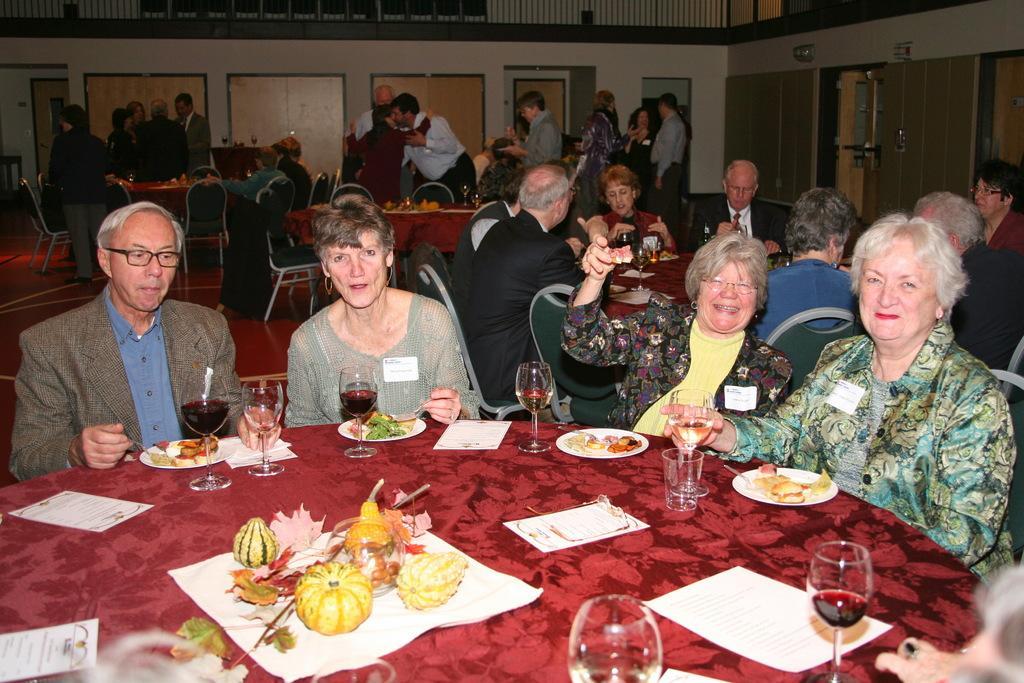Describe this image in one or two sentences. Few persons are sitting on chairs and few persons are standing. We can see plates,food,glasses and some objects on tables. On the background we can see wall and door. 